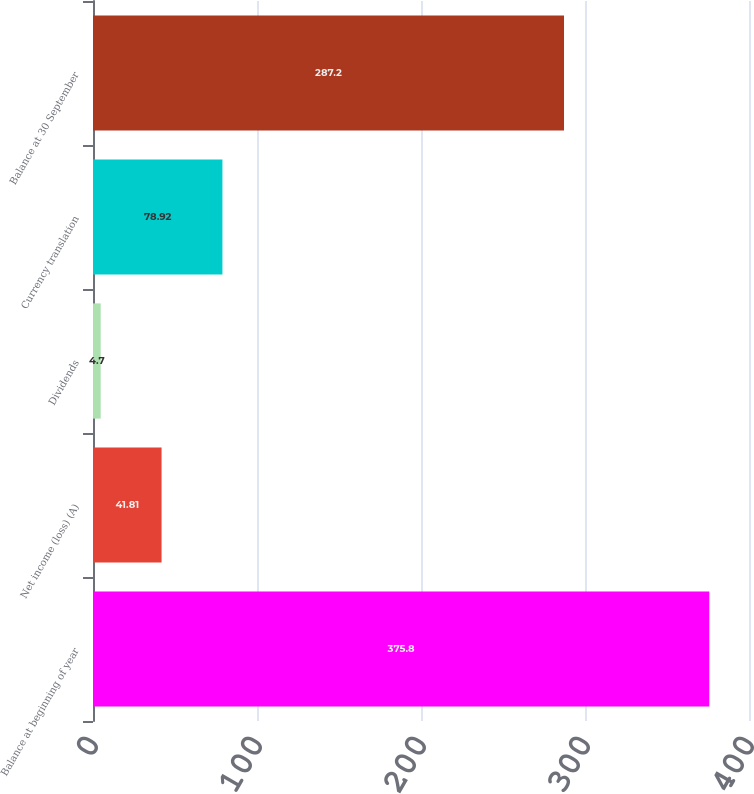<chart> <loc_0><loc_0><loc_500><loc_500><bar_chart><fcel>Balance at beginning of year<fcel>Net income (loss) (A)<fcel>Dividends<fcel>Currency translation<fcel>Balance at 30 September<nl><fcel>375.8<fcel>41.81<fcel>4.7<fcel>78.92<fcel>287.2<nl></chart> 